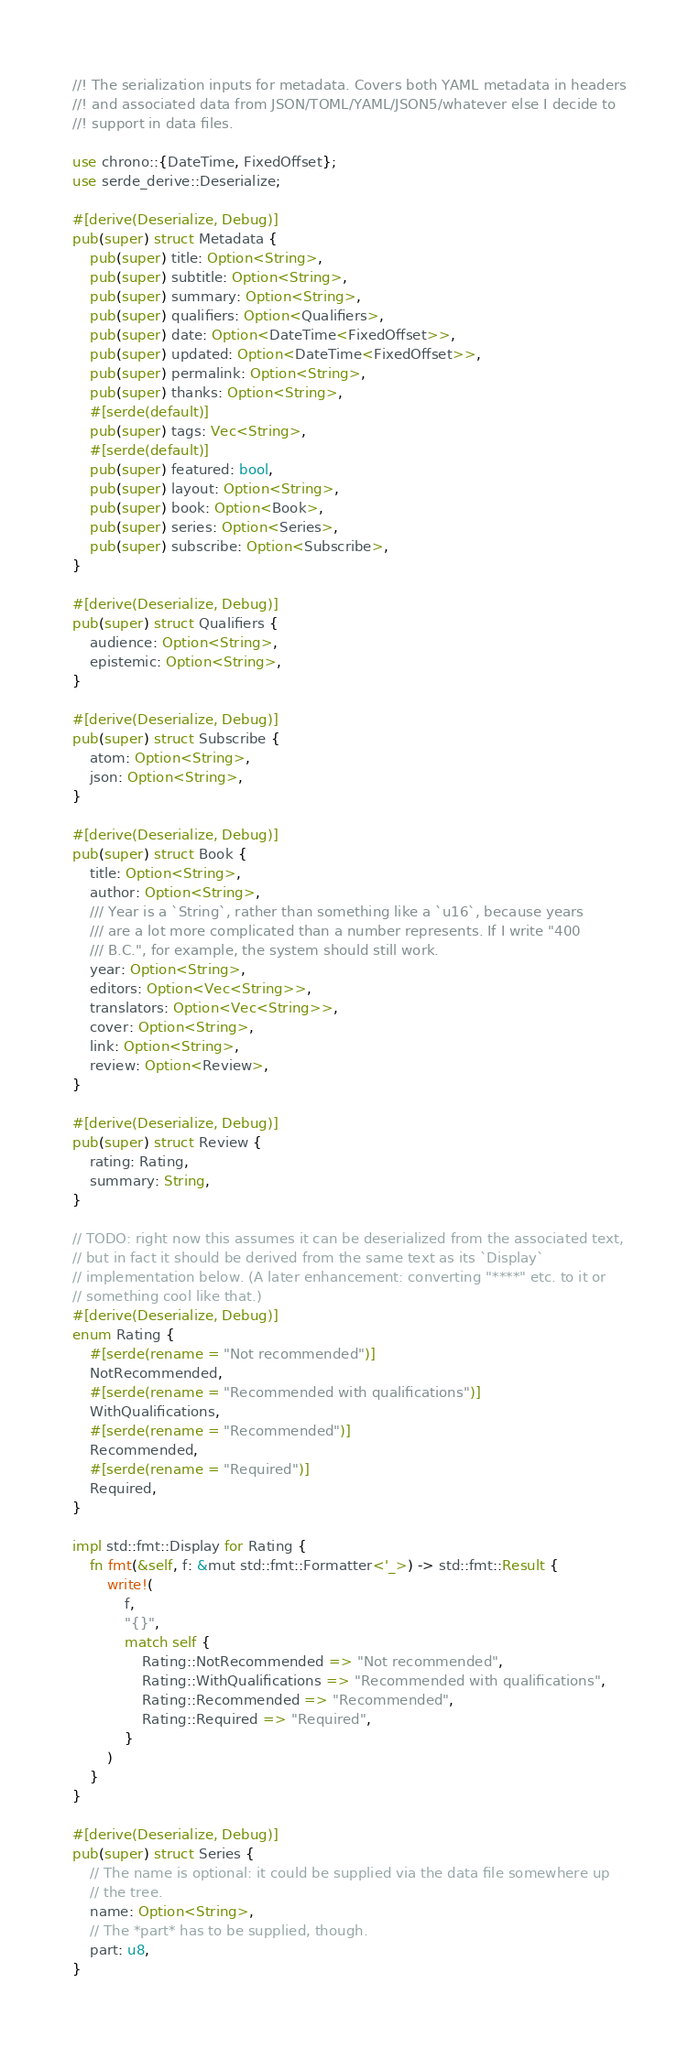Convert code to text. <code><loc_0><loc_0><loc_500><loc_500><_Rust_>//! The serialization inputs for metadata. Covers both YAML metadata in headers
//! and associated data from JSON/TOML/YAML/JSON5/whatever else I decide to
//! support in data files.

use chrono::{DateTime, FixedOffset};
use serde_derive::Deserialize;

#[derive(Deserialize, Debug)]
pub(super) struct Metadata {
    pub(super) title: Option<String>,
    pub(super) subtitle: Option<String>,
    pub(super) summary: Option<String>,
    pub(super) qualifiers: Option<Qualifiers>,
    pub(super) date: Option<DateTime<FixedOffset>>,
    pub(super) updated: Option<DateTime<FixedOffset>>,
    pub(super) permalink: Option<String>,
    pub(super) thanks: Option<String>,
    #[serde(default)]
    pub(super) tags: Vec<String>,
    #[serde(default)]
    pub(super) featured: bool,
    pub(super) layout: Option<String>,
    pub(super) book: Option<Book>,
    pub(super) series: Option<Series>,
    pub(super) subscribe: Option<Subscribe>,
}

#[derive(Deserialize, Debug)]
pub(super) struct Qualifiers {
    audience: Option<String>,
    epistemic: Option<String>,
}

#[derive(Deserialize, Debug)]
pub(super) struct Subscribe {
    atom: Option<String>,
    json: Option<String>,
}

#[derive(Deserialize, Debug)]
pub(super) struct Book {
    title: Option<String>,
    author: Option<String>,
    /// Year is a `String`, rather than something like a `u16`, because years
    /// are a lot more complicated than a number represents. If I write "400
    /// B.C.", for example, the system should still work.
    year: Option<String>,
    editors: Option<Vec<String>>,
    translators: Option<Vec<String>>,
    cover: Option<String>,
    link: Option<String>,
    review: Option<Review>,
}

#[derive(Deserialize, Debug)]
pub(super) struct Review {
    rating: Rating,
    summary: String,
}

// TODO: right now this assumes it can be deserialized from the associated text,
// but in fact it should be derived from the same text as its `Display`
// implementation below. (A later enhancement: converting "****" etc. to it or
// something cool like that.)
#[derive(Deserialize, Debug)]
enum Rating {
    #[serde(rename = "Not recommended")]
    NotRecommended,
    #[serde(rename = "Recommended with qualifications")]
    WithQualifications,
    #[serde(rename = "Recommended")]
    Recommended,
    #[serde(rename = "Required")]
    Required,
}

impl std::fmt::Display for Rating {
    fn fmt(&self, f: &mut std::fmt::Formatter<'_>) -> std::fmt::Result {
        write!(
            f,
            "{}",
            match self {
                Rating::NotRecommended => "Not recommended",
                Rating::WithQualifications => "Recommended with qualifications",
                Rating::Recommended => "Recommended",
                Rating::Required => "Required",
            }
        )
    }
}

#[derive(Deserialize, Debug)]
pub(super) struct Series {
    // The name is optional: it could be supplied via the data file somewhere up
    // the tree.
    name: Option<String>,
    // The *part* has to be supplied, though.
    part: u8,
}
</code> 